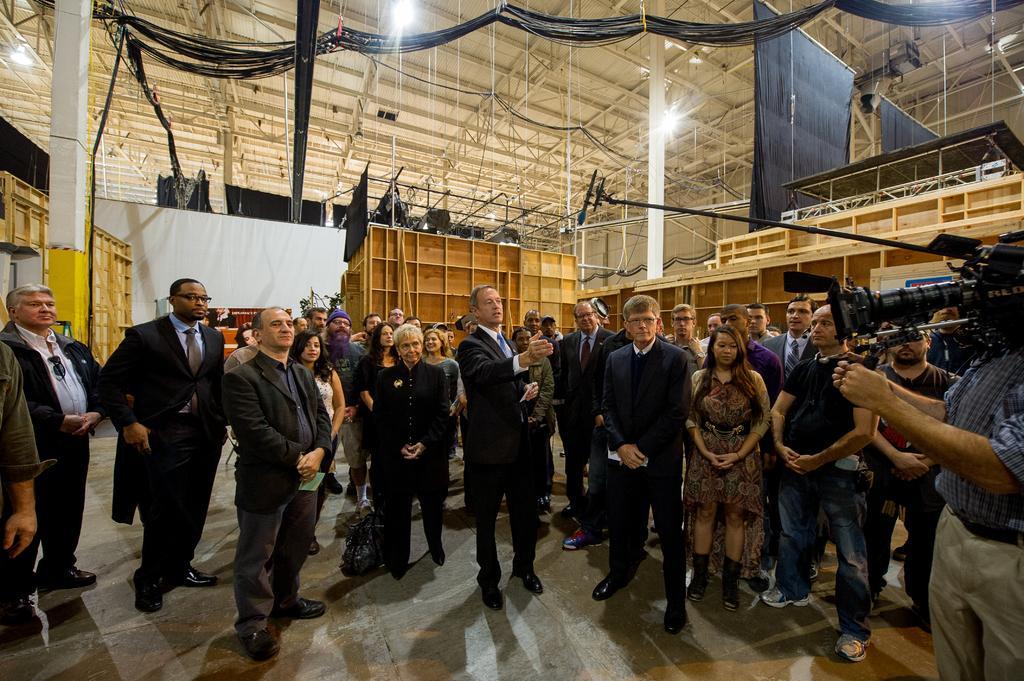Describe this image in one or two sentences. There are few people here standing on the floor and on the right a person is holding a camera on a stand in his hands. In the background there are wooden racks,wooden boards,poles,clothes,lights on the roof top and other objects. 